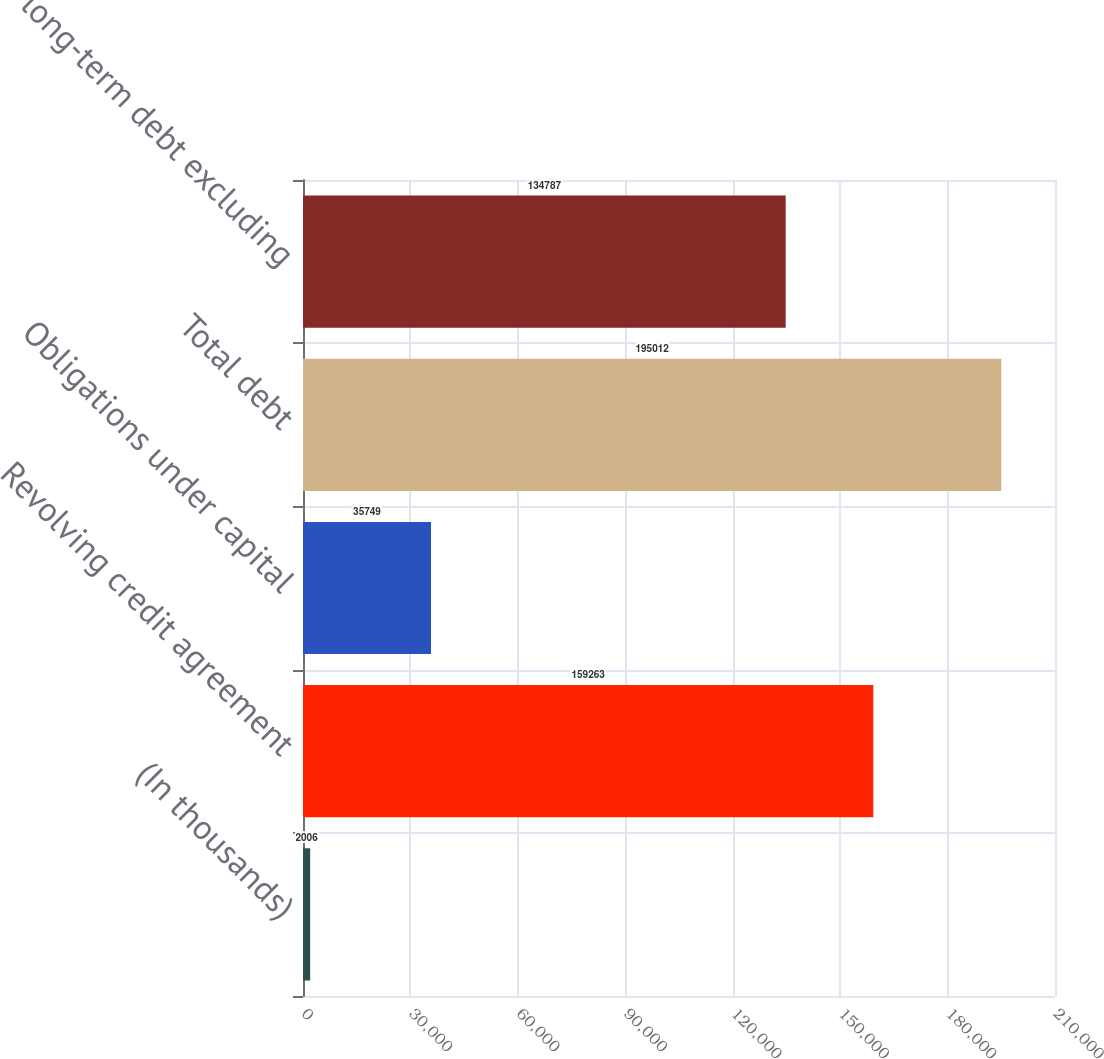<chart> <loc_0><loc_0><loc_500><loc_500><bar_chart><fcel>(In thousands)<fcel>Revolving credit agreement<fcel>Obligations under capital<fcel>Total debt<fcel>Total long-term debt excluding<nl><fcel>2006<fcel>159263<fcel>35749<fcel>195012<fcel>134787<nl></chart> 